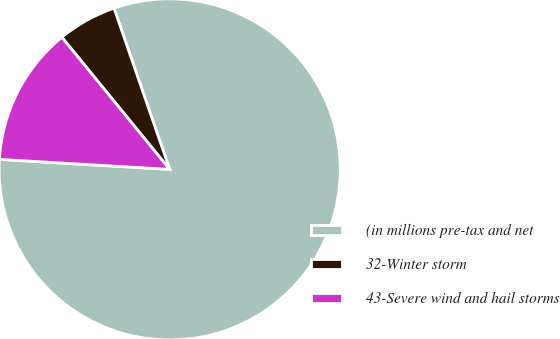Convert chart. <chart><loc_0><loc_0><loc_500><loc_500><pie_chart><fcel>(in millions pre-tax and net<fcel>32-Winter storm<fcel>43-Severe wind and hail storms<nl><fcel>81.23%<fcel>5.6%<fcel>13.17%<nl></chart> 